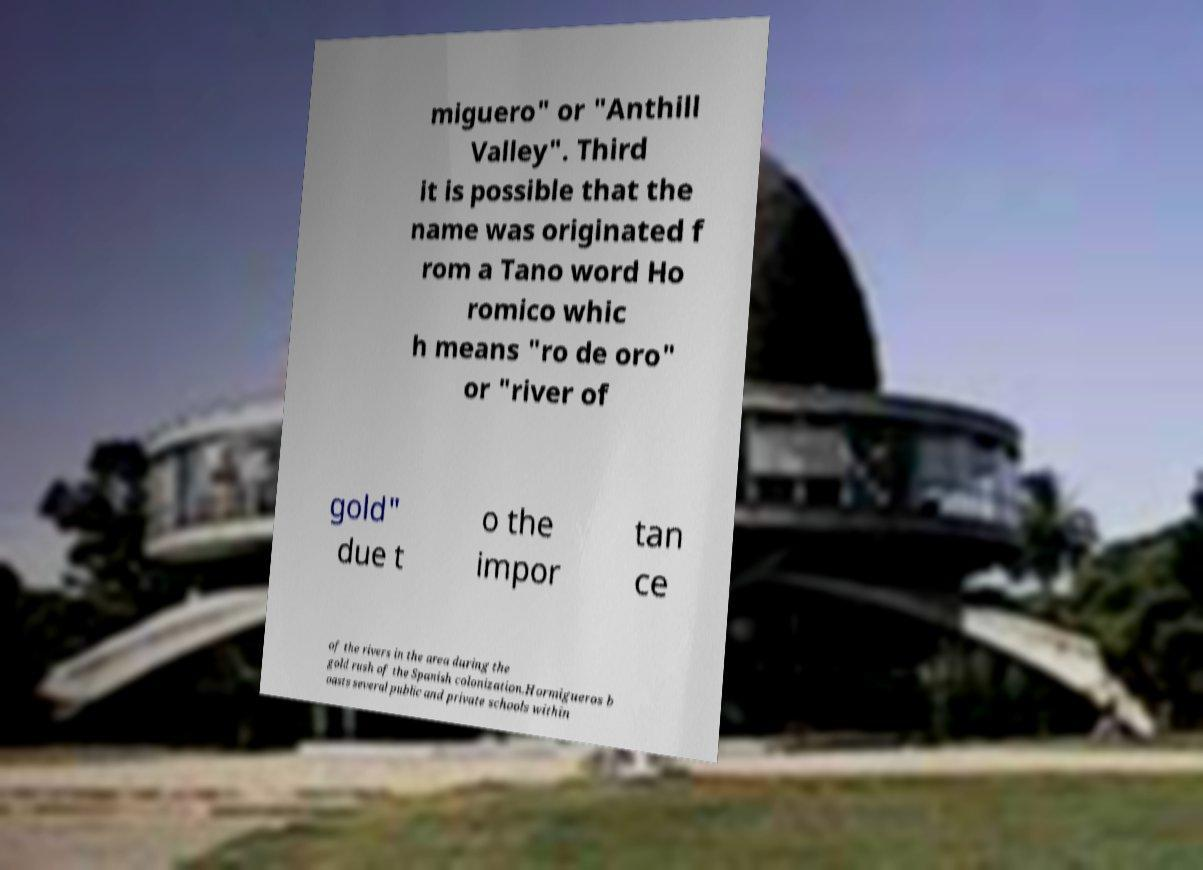I need the written content from this picture converted into text. Can you do that? miguero" or "Anthill Valley". Third it is possible that the name was originated f rom a Tano word Ho romico whic h means "ro de oro" or "river of gold" due t o the impor tan ce of the rivers in the area during the gold rush of the Spanish colonization.Hormigueros b oasts several public and private schools within 